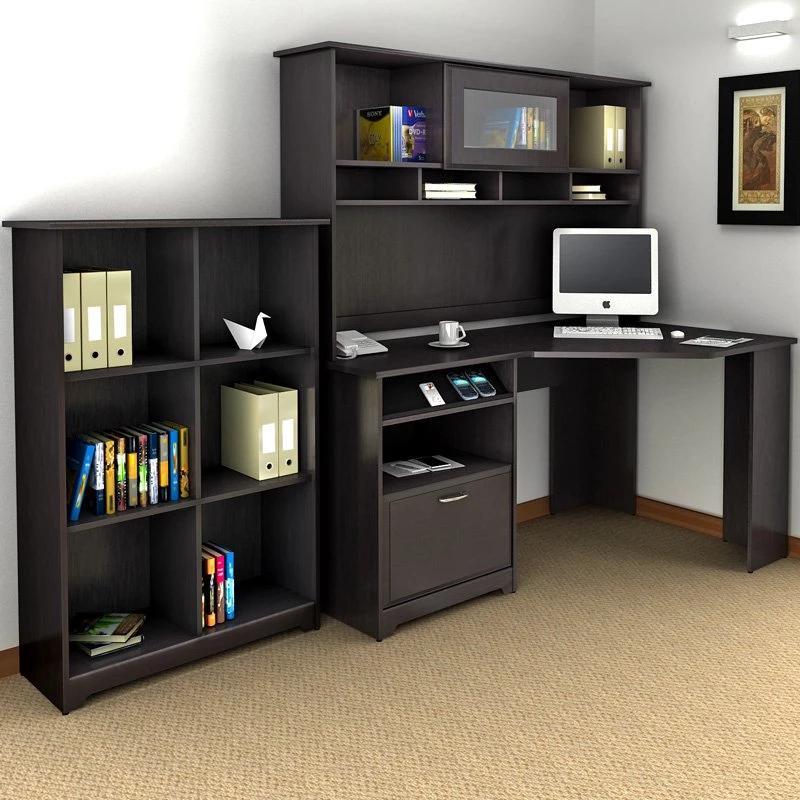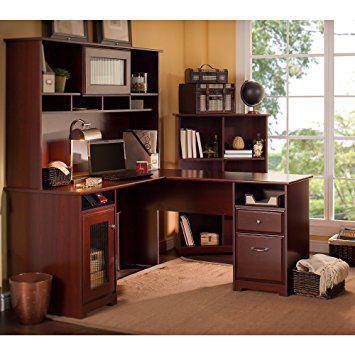The first image is the image on the left, the second image is the image on the right. Analyze the images presented: Is the assertion "The laptop screen is angled away from the front." valid? Answer yes or no. No. The first image is the image on the left, the second image is the image on the right. Analyze the images presented: Is the assertion "There is a chair in front of one of the office units." valid? Answer yes or no. No. 